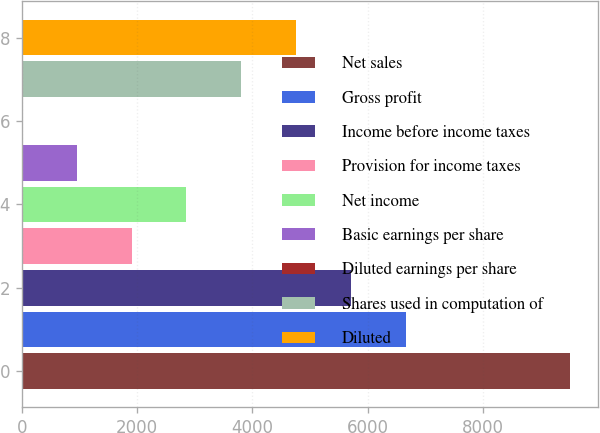<chart> <loc_0><loc_0><loc_500><loc_500><bar_chart><fcel>Net sales<fcel>Gross profit<fcel>Income before income taxes<fcel>Provision for income taxes<fcel>Net income<fcel>Basic earnings per share<fcel>Diluted earnings per share<fcel>Shares used in computation of<fcel>Diluted<nl><fcel>9519<fcel>6663.57<fcel>5711.75<fcel>1904.49<fcel>2856.31<fcel>952.67<fcel>0.85<fcel>3808.12<fcel>4759.93<nl></chart> 